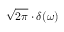<formula> <loc_0><loc_0><loc_500><loc_500>{ \sqrt { 2 \pi } } \cdot \delta ( \omega )</formula> 